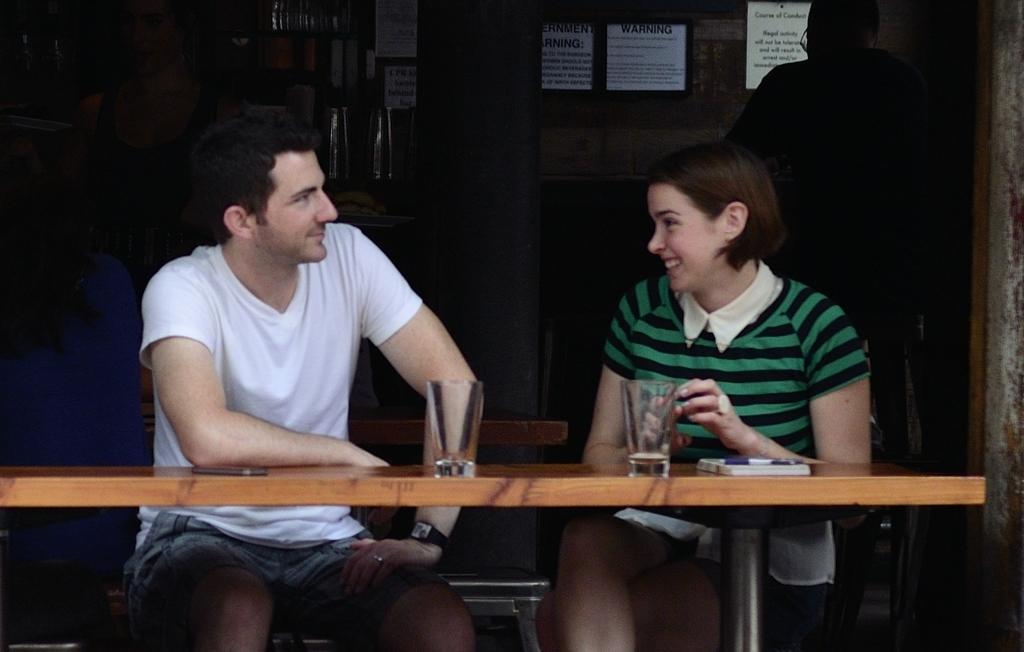Describe this image in one or two sentences. In the center of the image there are two people sitting on the chair. In front of them there is a table on which there is a glass. There are some other objects. In the background of the image there is a wall on which there are papers. To the right side of the image there is a person. 